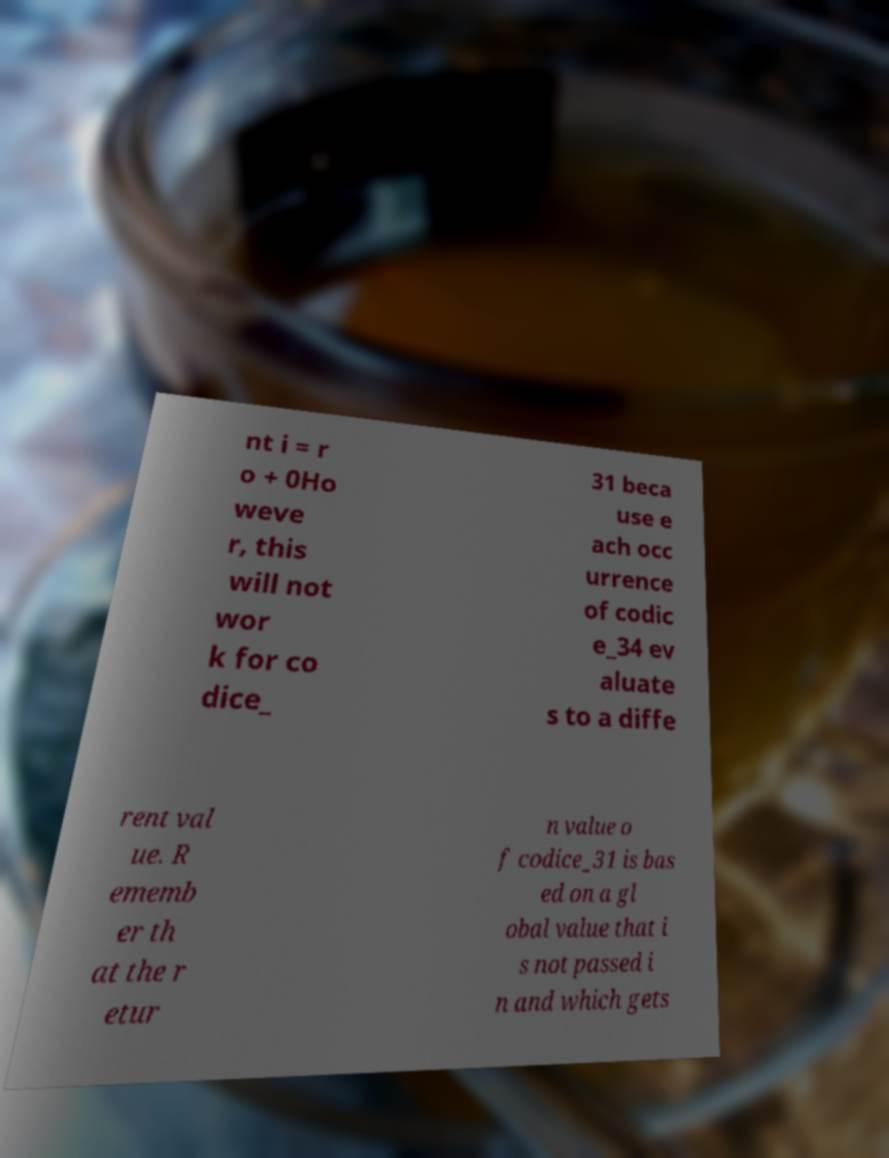Could you extract and type out the text from this image? nt i = r o + 0Ho weve r, this will not wor k for co dice_ 31 beca use e ach occ urrence of codic e_34 ev aluate s to a diffe rent val ue. R ememb er th at the r etur n value o f codice_31 is bas ed on a gl obal value that i s not passed i n and which gets 